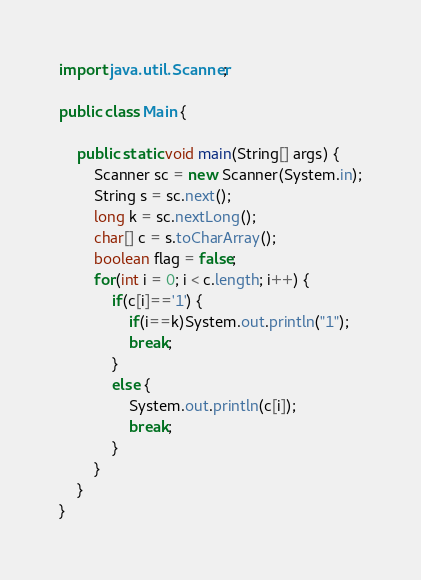<code> <loc_0><loc_0><loc_500><loc_500><_Java_>import java.util.Scanner;

public class Main {

	public static void main(String[] args) {
		Scanner sc = new Scanner(System.in);
		String s = sc.next();
		long k = sc.nextLong();
		char[] c = s.toCharArray();
		boolean flag = false;
		for(int i = 0; i < c.length; i++) {
			if(c[i]=='1') {
				if(i==k)System.out.println("1");
				break;
			}
			else {
				System.out.println(c[i]);
				break;
			}
		}
	}
}</code> 